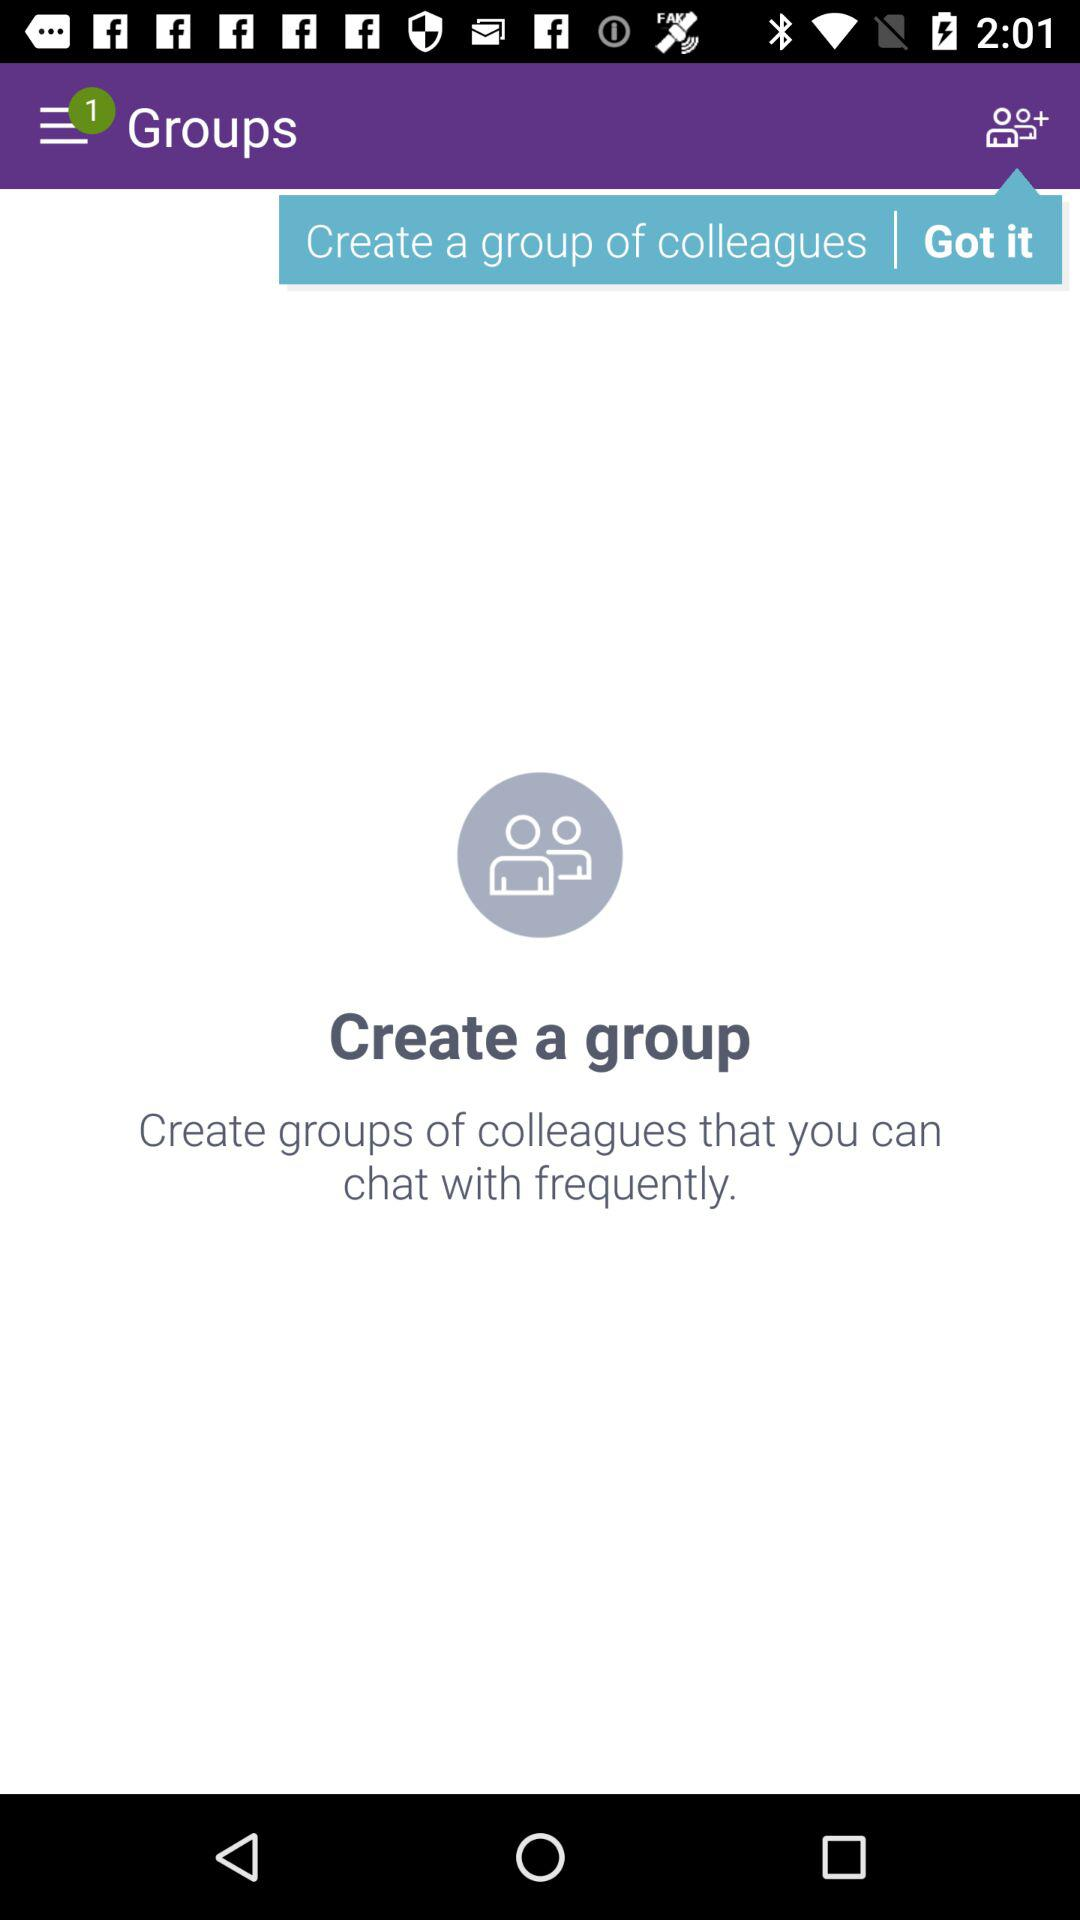How many notifications are shown in the menu bar? There is 1 notification shown in the menu bar. 